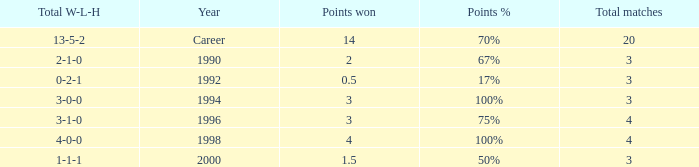Can you tell me the lowest Points won that has the Total matches of 4, and the Total W-L-H of 4-0-0? 4.0. 